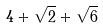Convert formula to latex. <formula><loc_0><loc_0><loc_500><loc_500>4 + \sqrt { 2 } + \sqrt { 6 }</formula> 